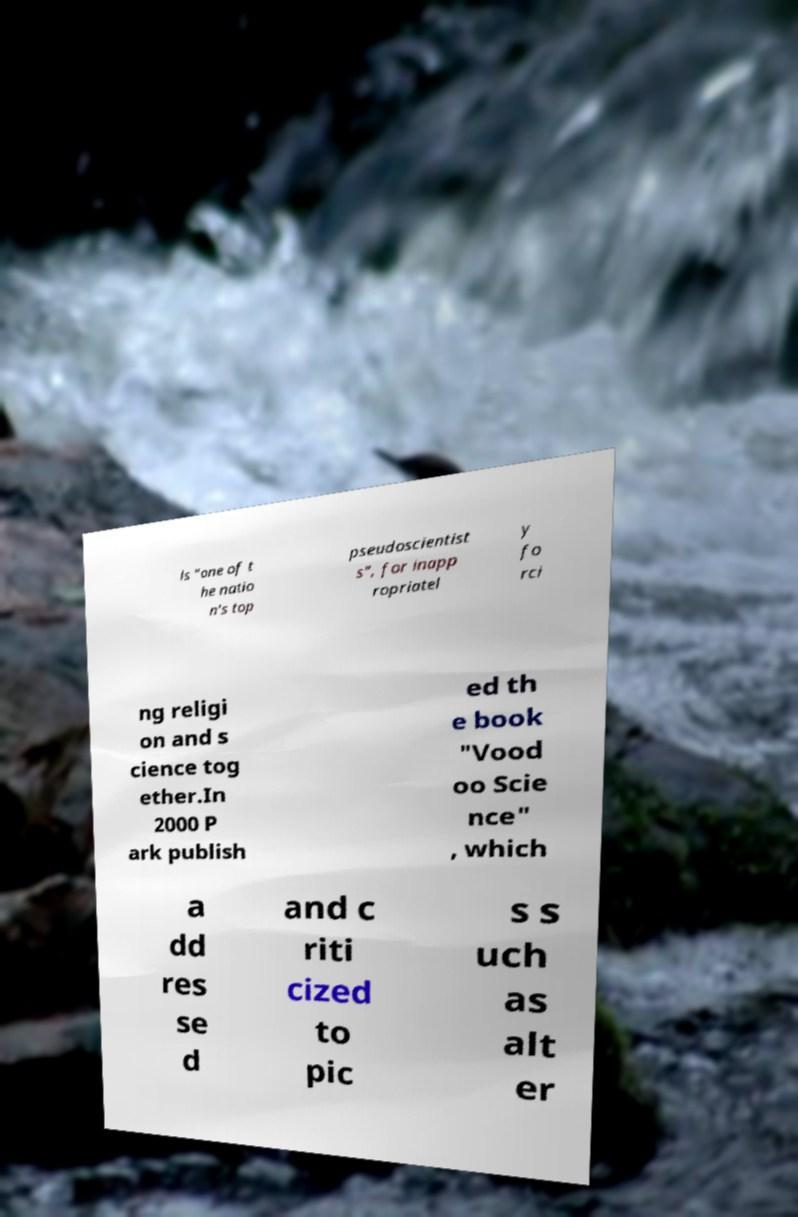There's text embedded in this image that I need extracted. Can you transcribe it verbatim? ls "one of t he natio n's top pseudoscientist s", for inapp ropriatel y fo rci ng religi on and s cience tog ether.In 2000 P ark publish ed th e book "Vood oo Scie nce" , which a dd res se d and c riti cized to pic s s uch as alt er 